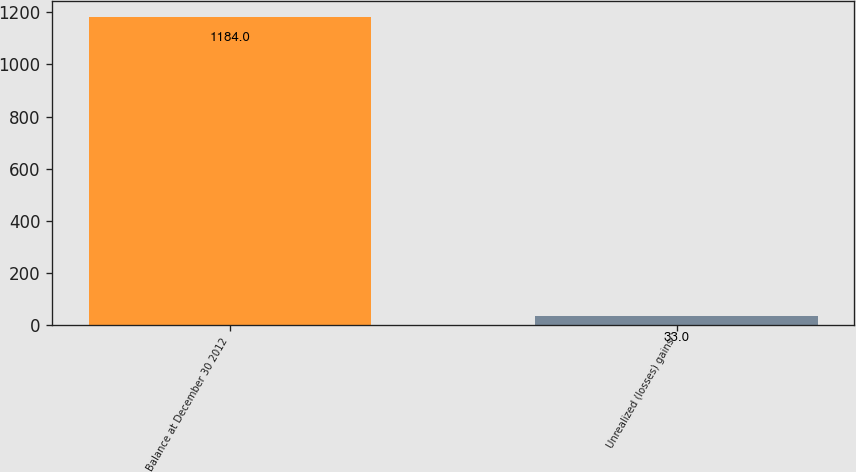Convert chart to OTSL. <chart><loc_0><loc_0><loc_500><loc_500><bar_chart><fcel>Balance at December 30 2012<fcel>Unrealized (losses) gains<nl><fcel>1184<fcel>33<nl></chart> 